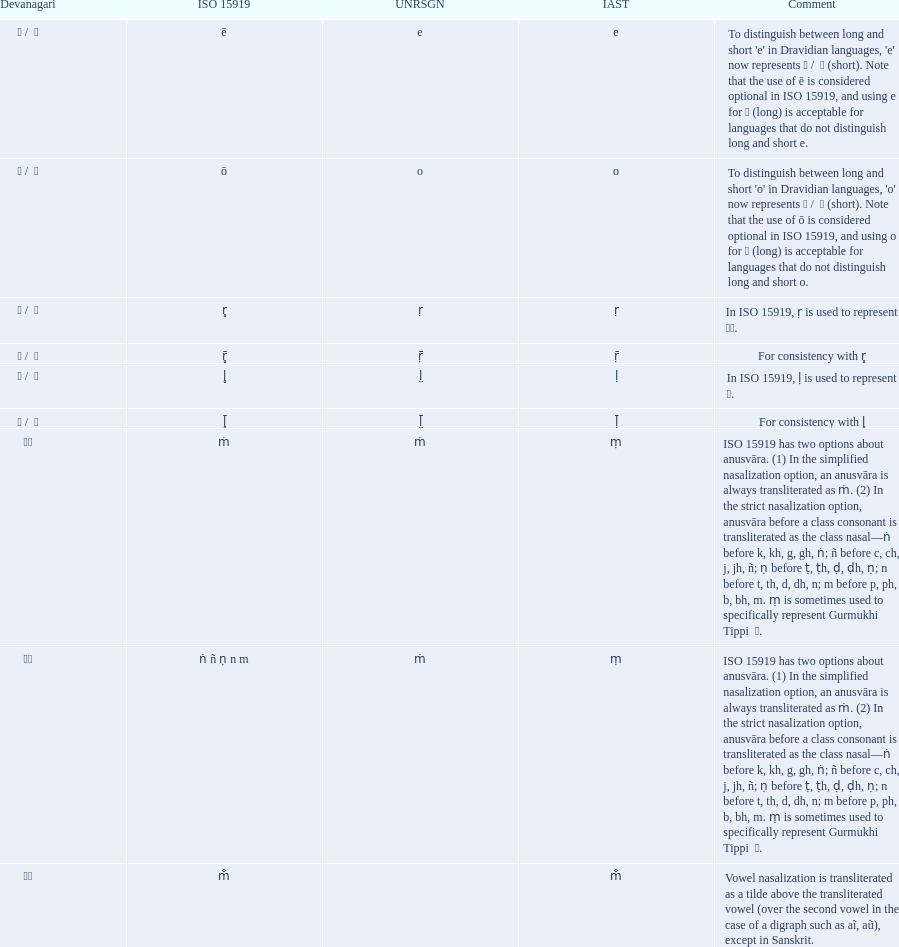What is listed previous to in iso 15919, &#7735; is used to represent &#2355;. under comments? For consistency with r̥. 